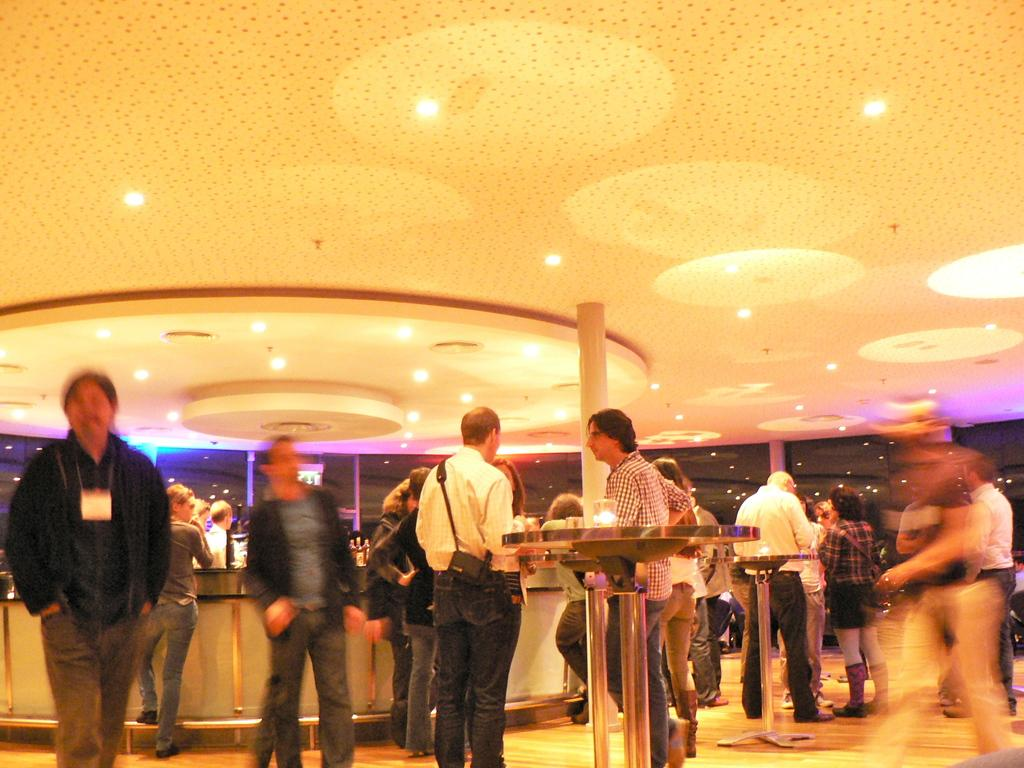Who or what can be seen in the image? There are people in the image. What type of furniture is present in the image? There are tables in the image. What is hanging from the ceiling in the image? Lights are attached to the ceiling. What architectural elements can be seen in the image? There are pillars in the image. How many ants are crawling on the tables in the image? There are no ants present in the image; the tables are clear of any insects. 